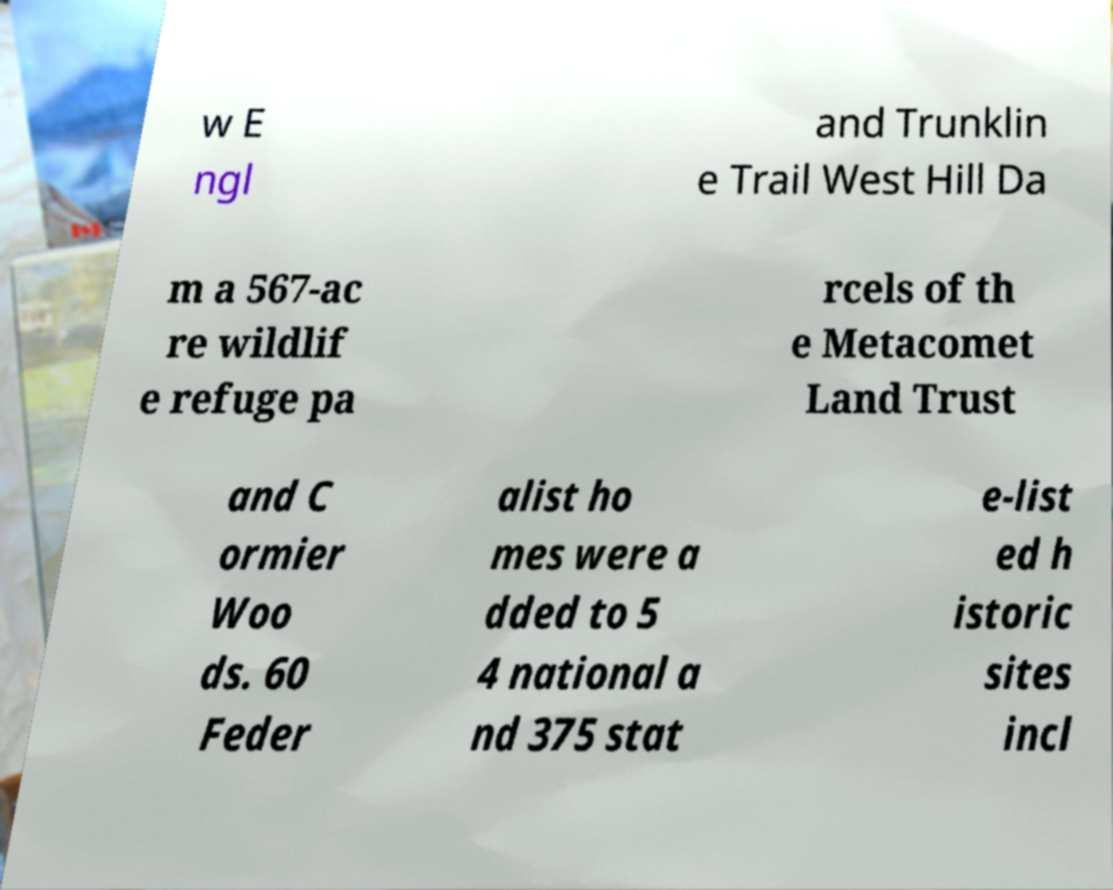There's text embedded in this image that I need extracted. Can you transcribe it verbatim? w E ngl and Trunklin e Trail West Hill Da m a 567-ac re wildlif e refuge pa rcels of th e Metacomet Land Trust and C ormier Woo ds. 60 Feder alist ho mes were a dded to 5 4 national a nd 375 stat e-list ed h istoric sites incl 